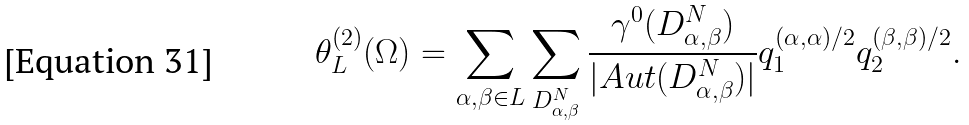<formula> <loc_0><loc_0><loc_500><loc_500>\theta _ { L } ^ { ( 2 ) } ( \Omega ) = \sum _ { \alpha , \beta \in L } \sum _ { D _ { \alpha , \beta } ^ { N } } \frac { \gamma ^ { 0 } ( D _ { \alpha , \beta } ^ { N } ) } { | A u t ( D _ { \alpha , \beta } ^ { N } ) | } q _ { 1 } ^ { ( \alpha , \alpha ) / 2 } q _ { 2 } ^ { ( \beta , \beta ) / 2 } .</formula> 